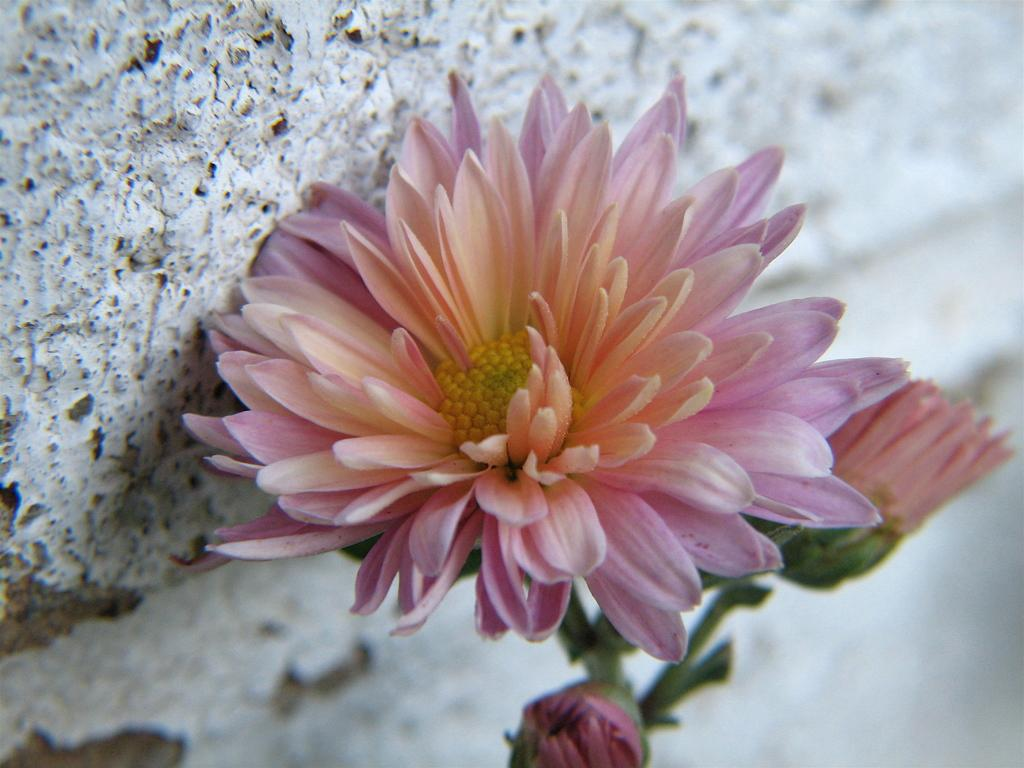What color are the flowers in the image? The flowers in the image are pink. What else can be seen connected to the flowers? There are stems associated with the flowers. What is visible in the background of the image? There appears to be a wall in the background of the image. How many dimes can be seen floating in the liquid in the image? There is no liquid or dimes present in the image; it features pink flowers with stems and a wall in the background. 